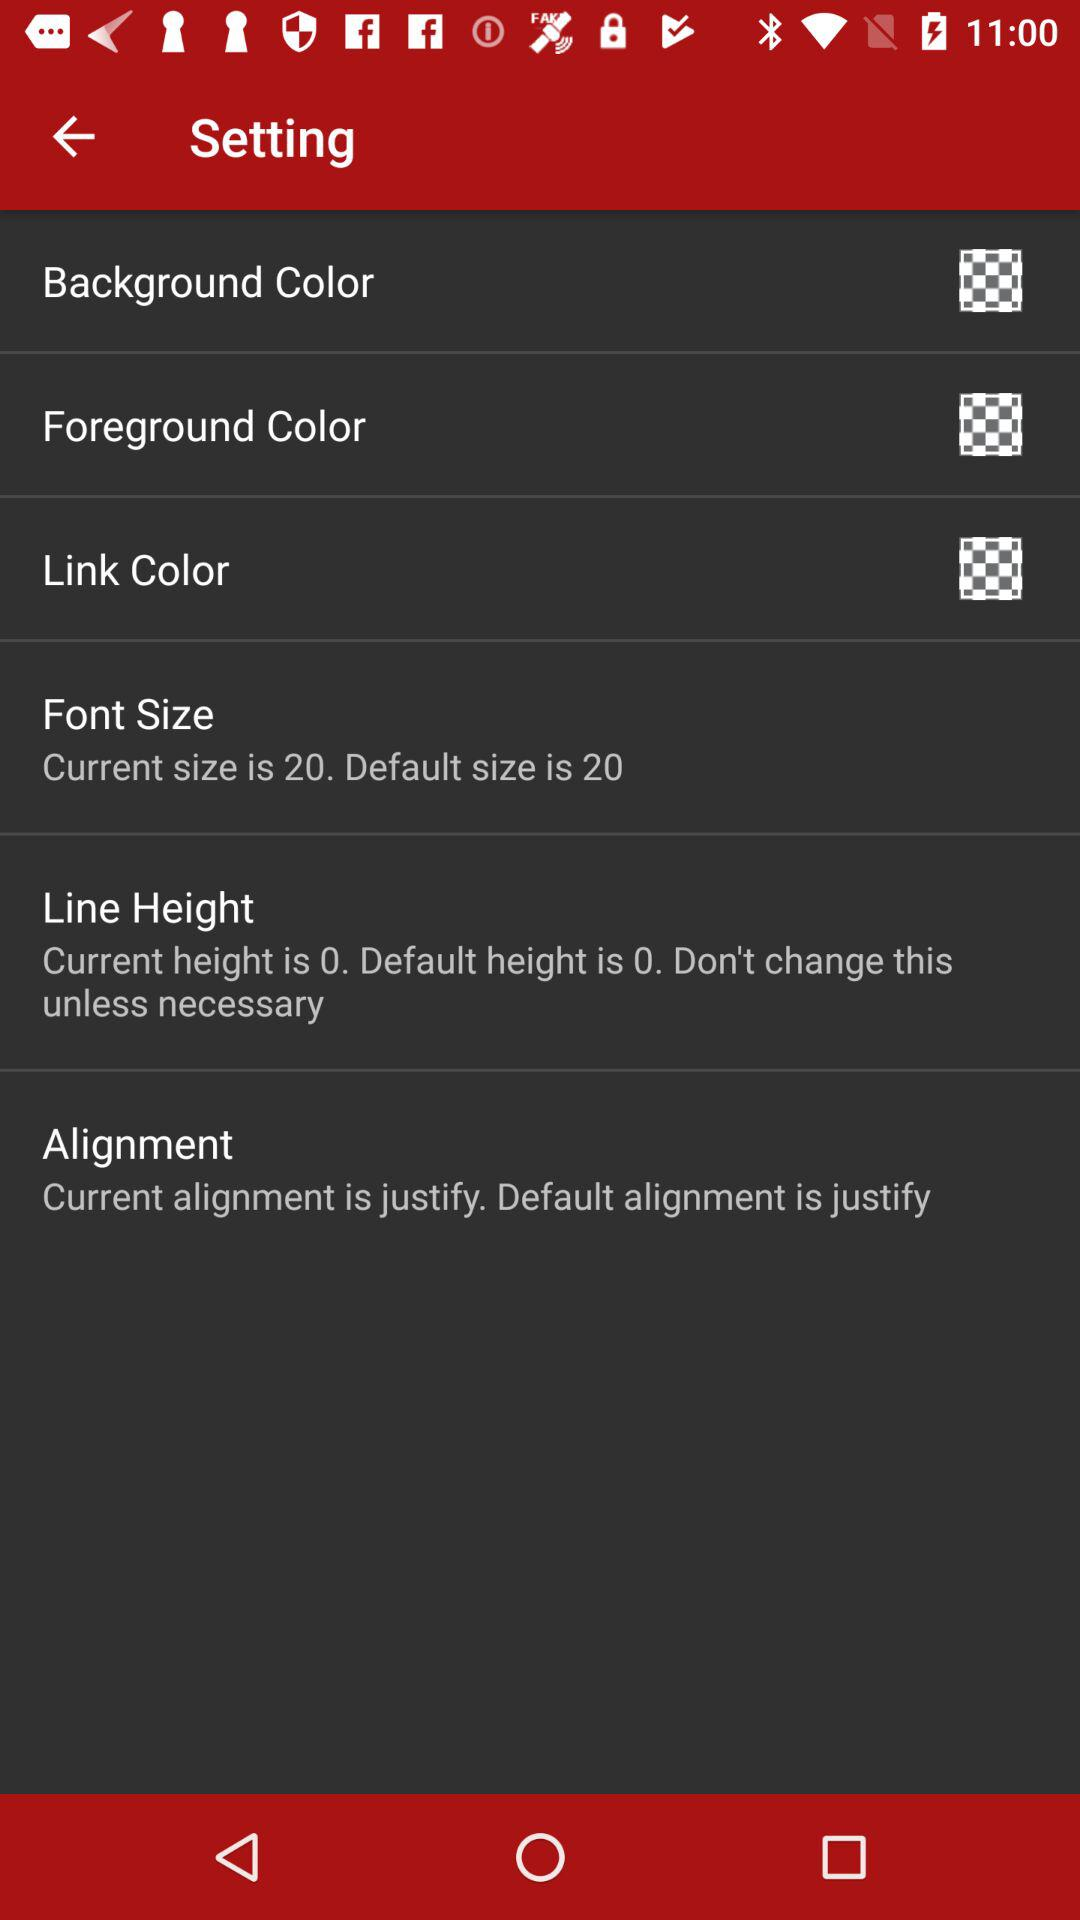What is the selected line height? The selected line height is 0. 